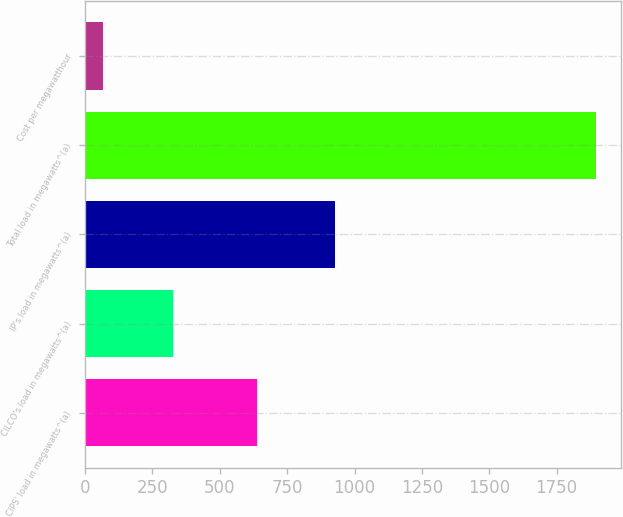<chart> <loc_0><loc_0><loc_500><loc_500><bar_chart><fcel>CIPS' load in megawatts^(a)<fcel>CILCO's load in megawatts^(a)<fcel>IP's load in megawatts^(a)<fcel>Total load in megawatts^(a)<fcel>Cost per megawatthour<nl><fcel>639<fcel>328<fcel>928<fcel>1895<fcel>66.05<nl></chart> 